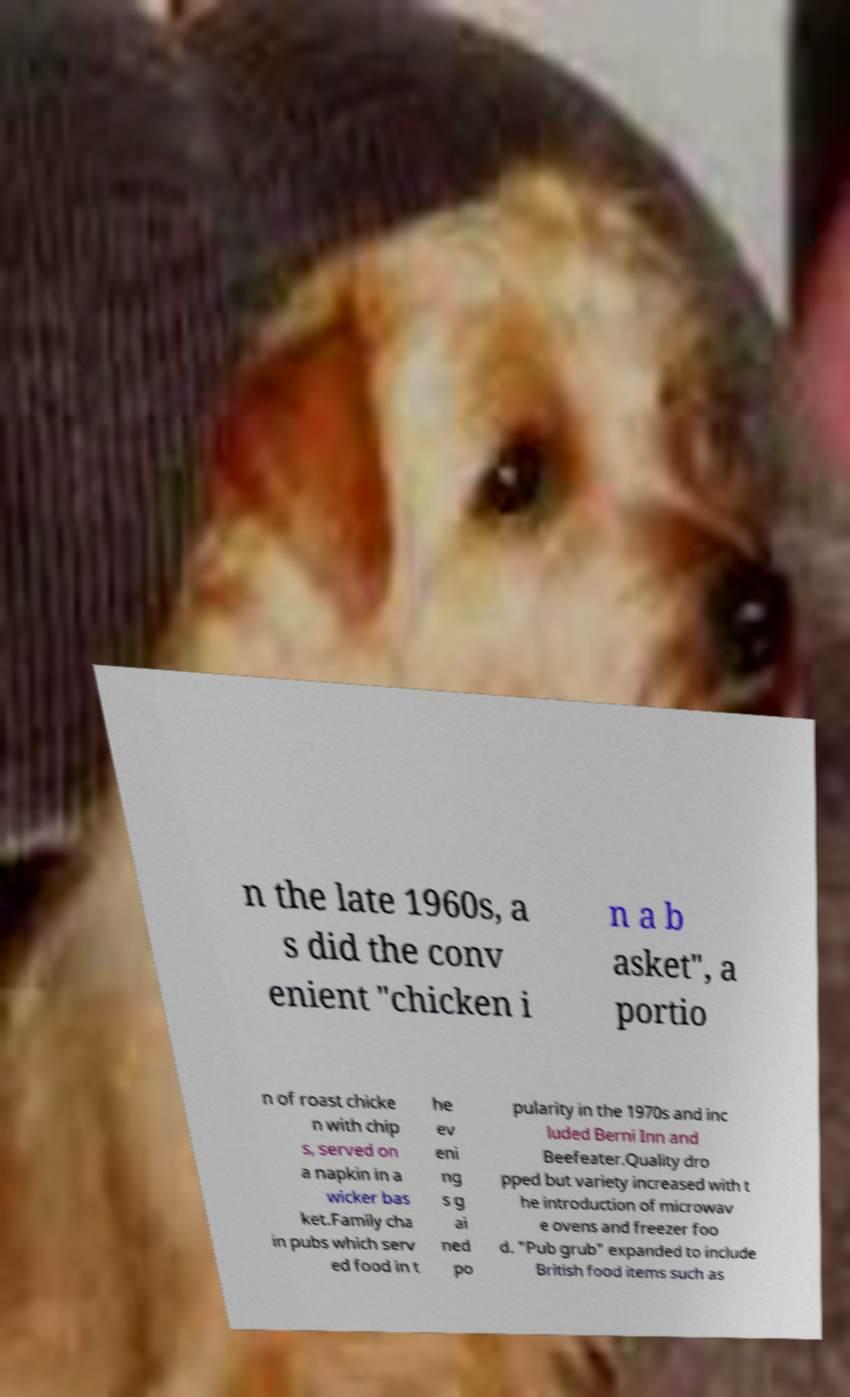Please identify and transcribe the text found in this image. n the late 1960s, a s did the conv enient "chicken i n a b asket", a portio n of roast chicke n with chip s, served on a napkin in a wicker bas ket.Family cha in pubs which serv ed food in t he ev eni ng s g ai ned po pularity in the 1970s and inc luded Berni Inn and Beefeater.Quality dro pped but variety increased with t he introduction of microwav e ovens and freezer foo d. "Pub grub" expanded to include British food items such as 